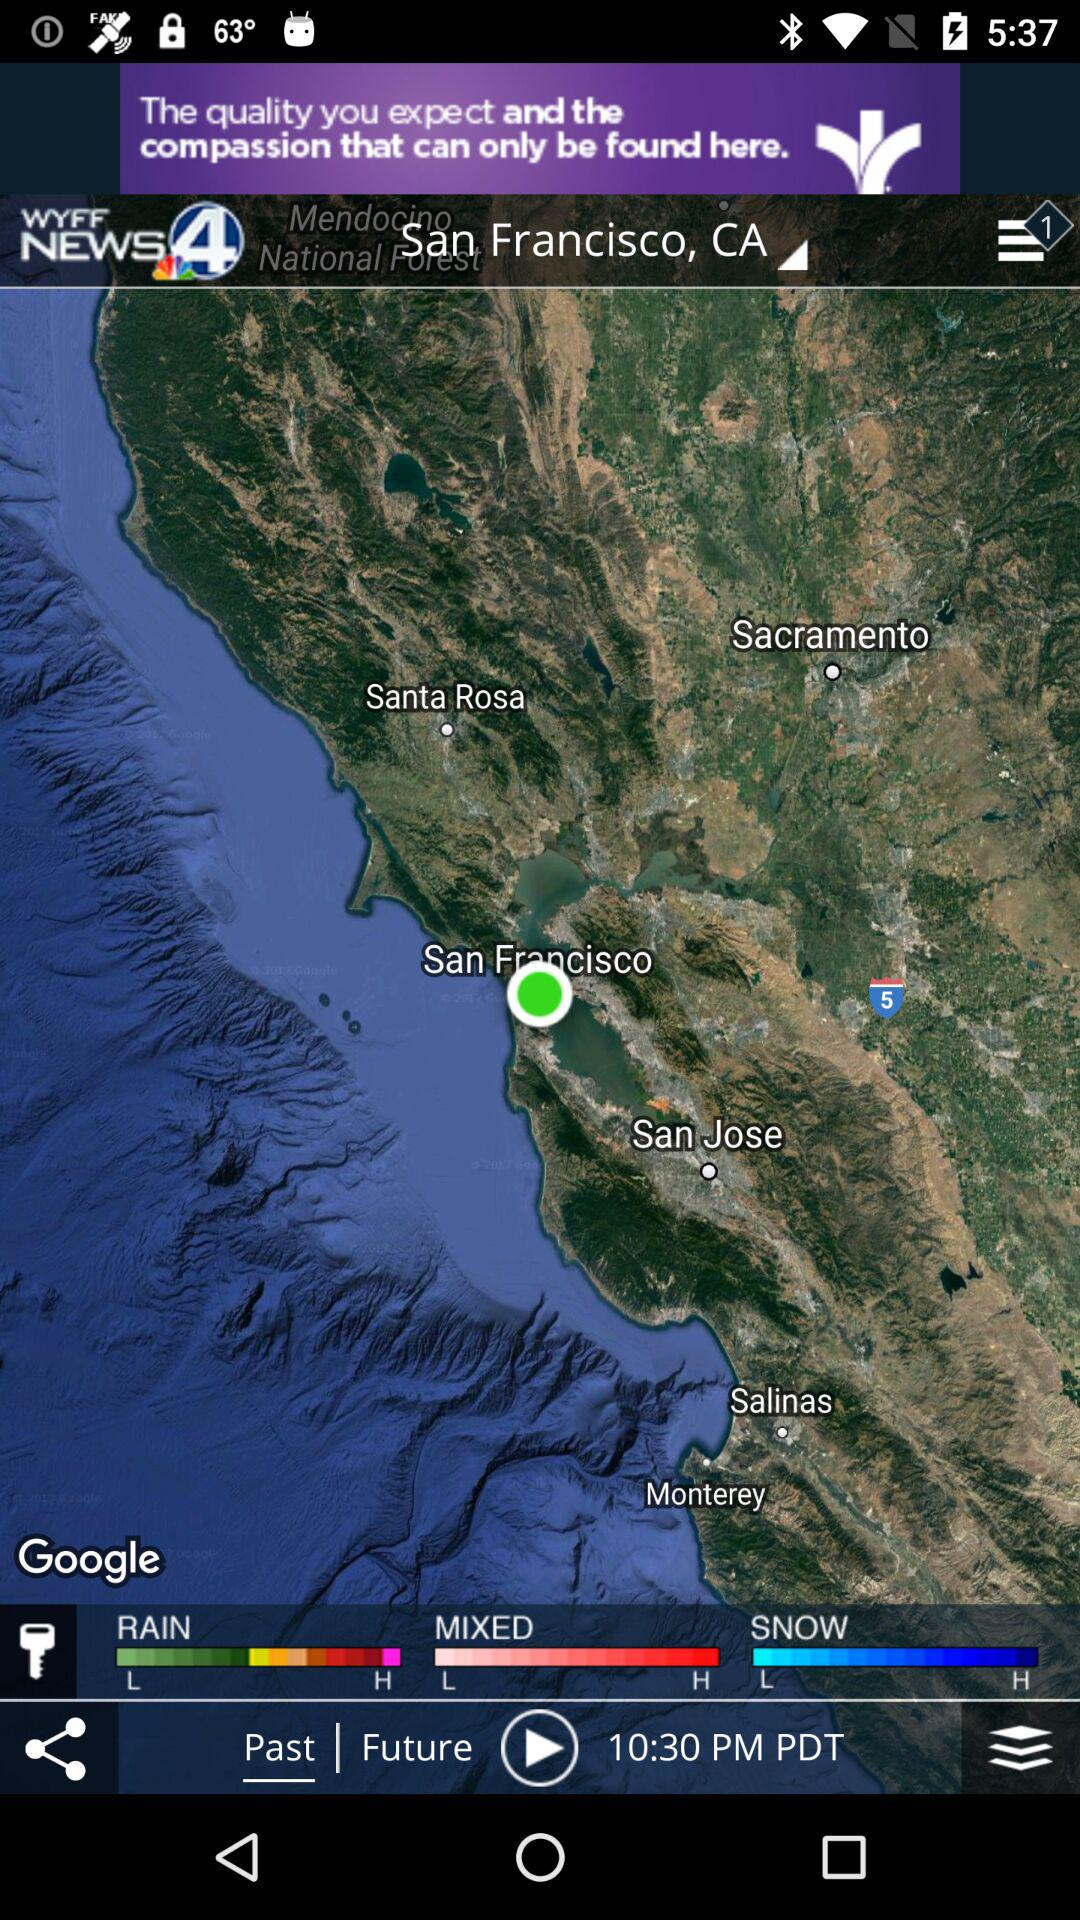How many weather conditions are displayed?
Answer the question using a single word or phrase. 3 